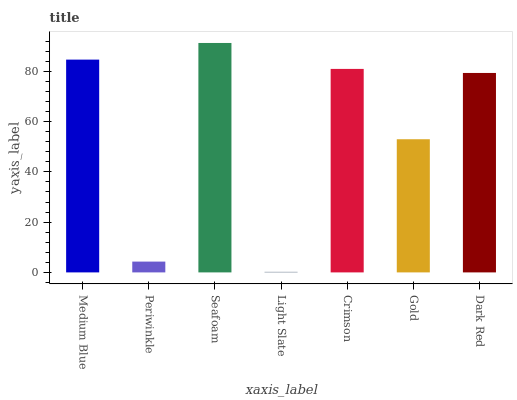Is Light Slate the minimum?
Answer yes or no. Yes. Is Seafoam the maximum?
Answer yes or no. Yes. Is Periwinkle the minimum?
Answer yes or no. No. Is Periwinkle the maximum?
Answer yes or no. No. Is Medium Blue greater than Periwinkle?
Answer yes or no. Yes. Is Periwinkle less than Medium Blue?
Answer yes or no. Yes. Is Periwinkle greater than Medium Blue?
Answer yes or no. No. Is Medium Blue less than Periwinkle?
Answer yes or no. No. Is Dark Red the high median?
Answer yes or no. Yes. Is Dark Red the low median?
Answer yes or no. Yes. Is Crimson the high median?
Answer yes or no. No. Is Seafoam the low median?
Answer yes or no. No. 